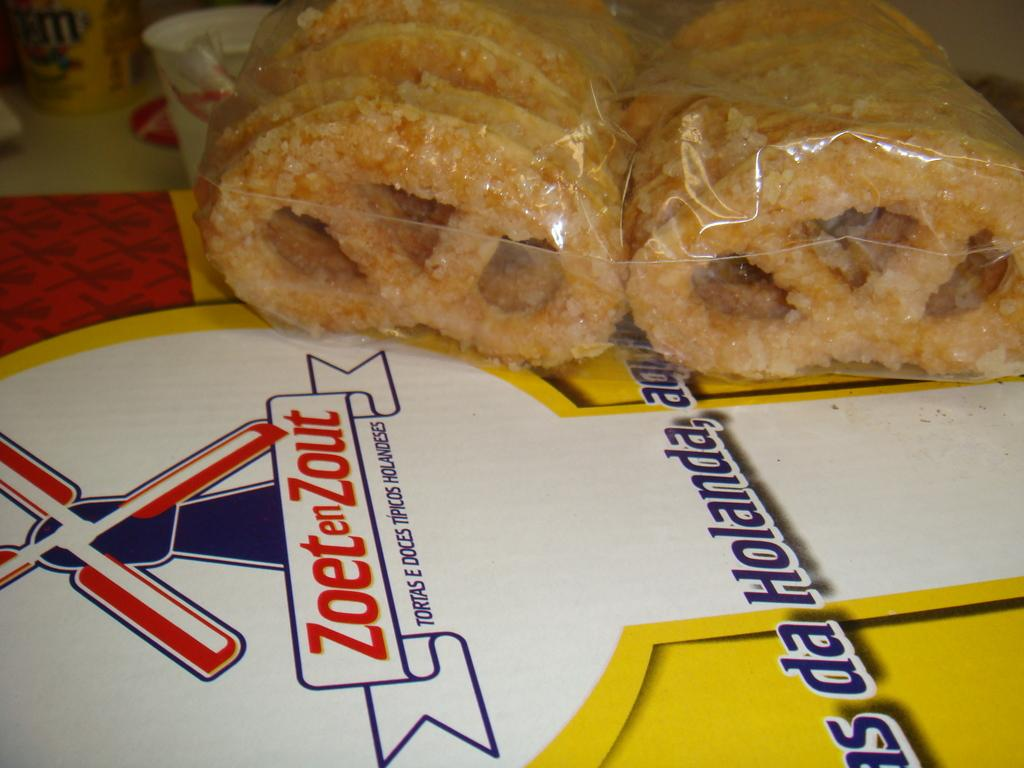What is the main subject of the image? The main subject of the image is food. How is the food being stored or presented? The food is packed in a cover. Is there any additional information about the food in the image? Yes, there is a card with food information at the bottom of the image. What else can be seen in the image besides the food? There is a cup on the left side of the image. What type of marble is being used for the activity in the image? There is no marble or activity present in the image; it features food packed in a cover and a cup on the left side. 